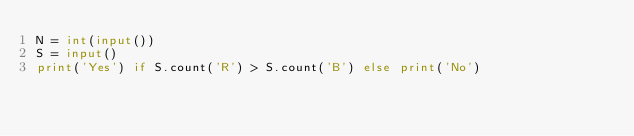Convert code to text. <code><loc_0><loc_0><loc_500><loc_500><_Python_>N = int(input())
S = input()
print('Yes') if S.count('R') > S.count('B') else print('No')</code> 